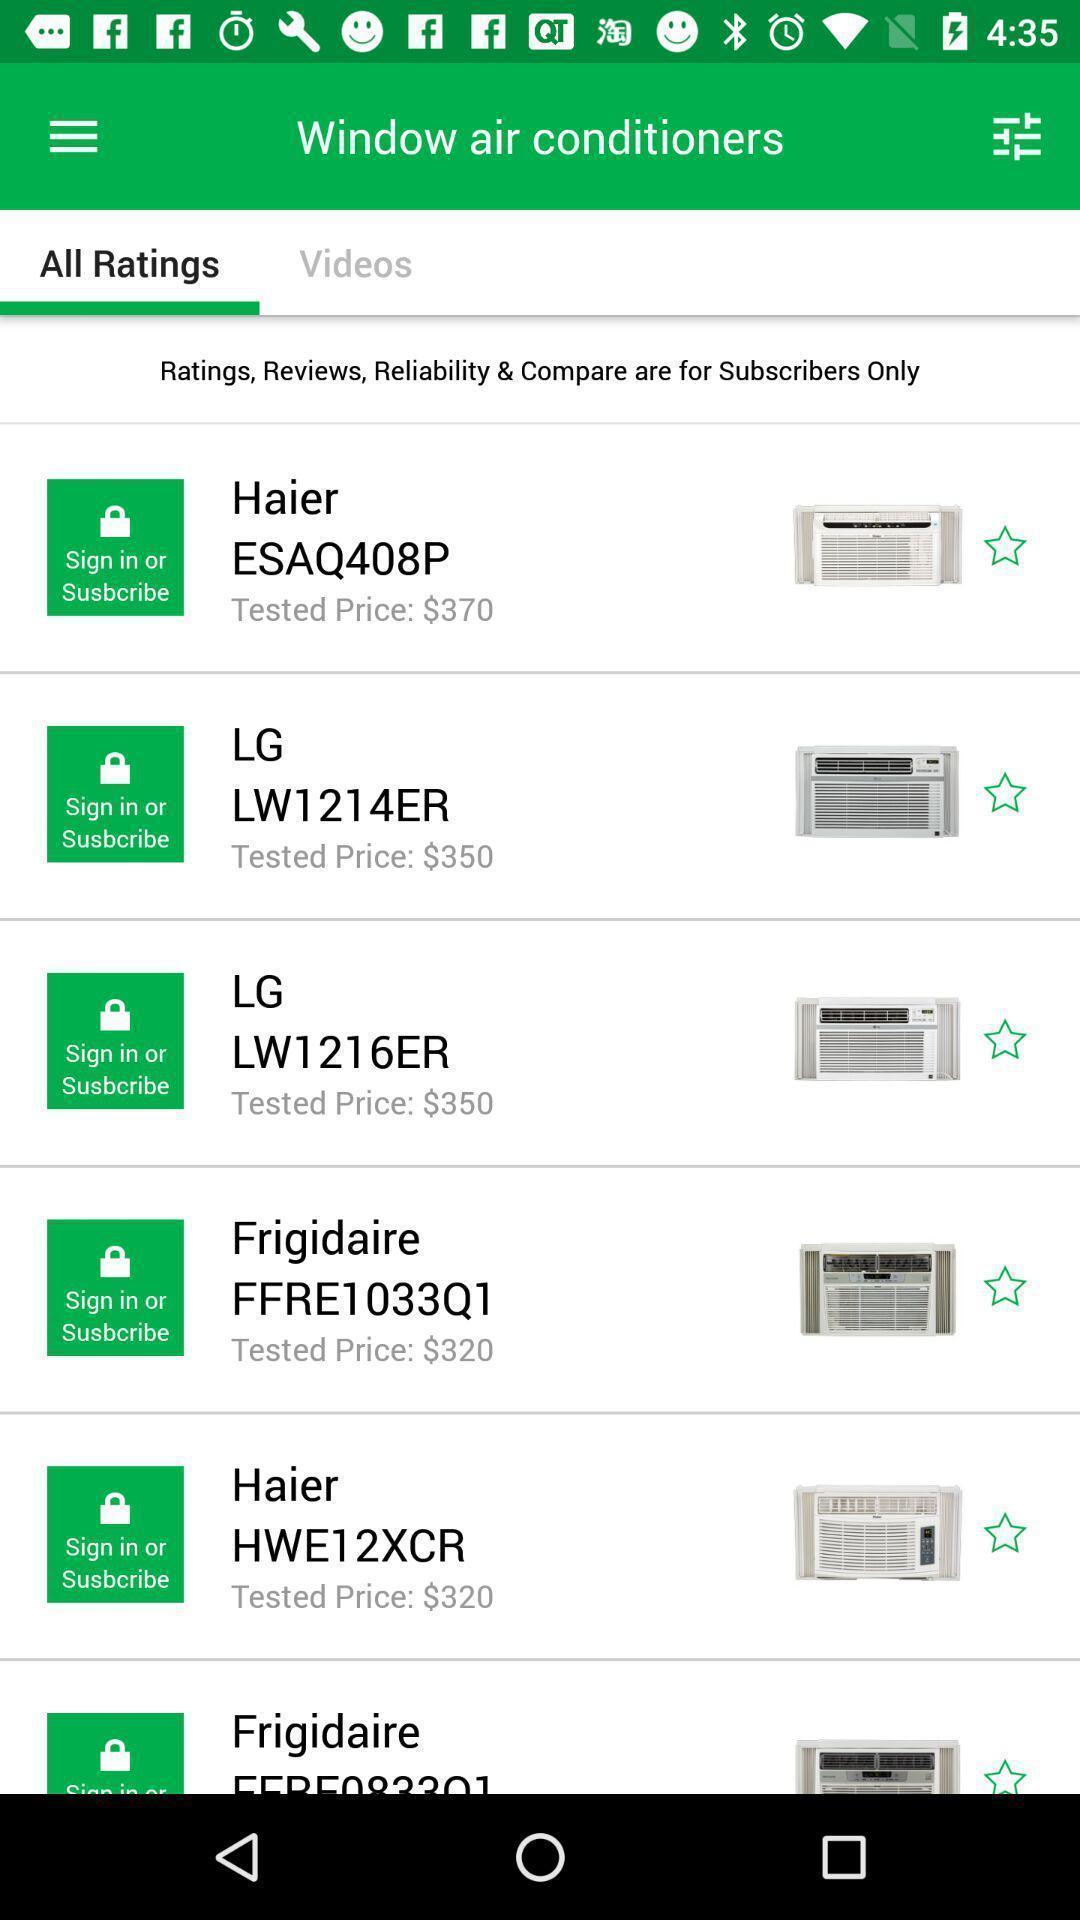Give me a summary of this screen capture. Screen shows list of ratings in a shopping app. 